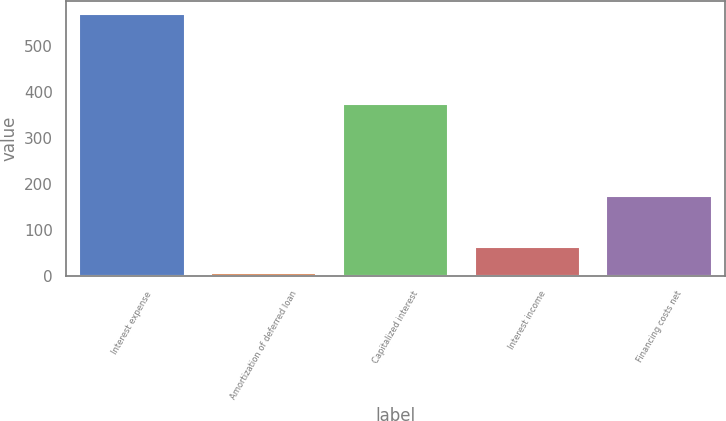<chart> <loc_0><loc_0><loc_500><loc_500><bar_chart><fcel>Interest expense<fcel>Amortization of deferred loan<fcel>Capitalized interest<fcel>Interest income<fcel>Financing costs net<nl><fcel>571<fcel>8<fcel>374<fcel>64.3<fcel>174<nl></chart> 